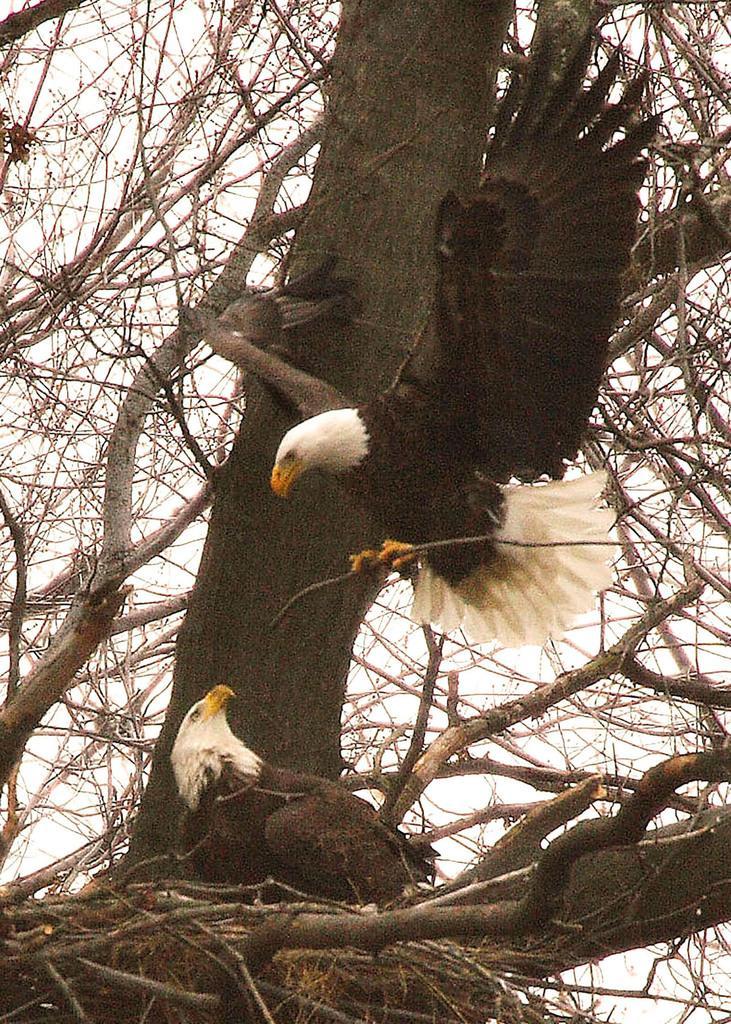Please provide a concise description of this image. In this image I can see the birds which are in white and black color. In the back I can see the dried trees and the sky. 